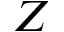Convert formula to latex. <formula><loc_0><loc_0><loc_500><loc_500>Z</formula> 